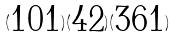<formula> <loc_0><loc_0><loc_500><loc_500>( \begin{matrix} 1 0 1 \end{matrix} ) ( \begin{matrix} 4 2 \end{matrix} ) ( \begin{matrix} 3 6 1 \end{matrix} )</formula> 